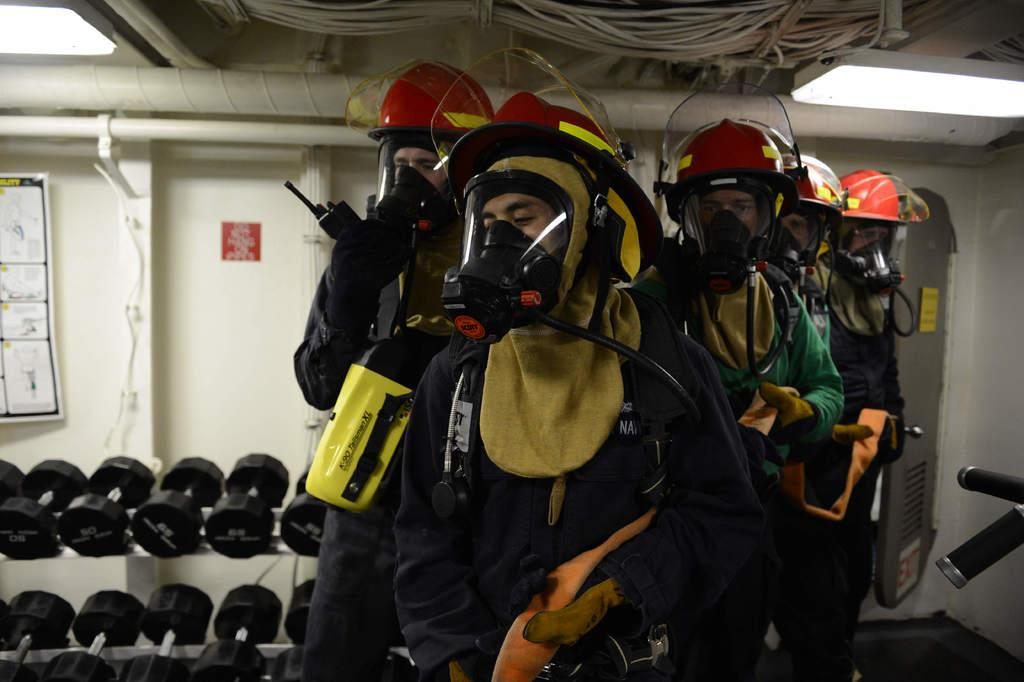What are the people in the image wearing on their heads? The people in the image are wearing oxygen helmets. What can be seen in the background of the image? There are dumbbells visible in the background of the image. What is present at the top of the image? There are wires visible at the top of the image. What is placed on the wall in the image? There is a board placed on the wall in the image. How many quilts are visible in the image? There are no quilts present in the image. 